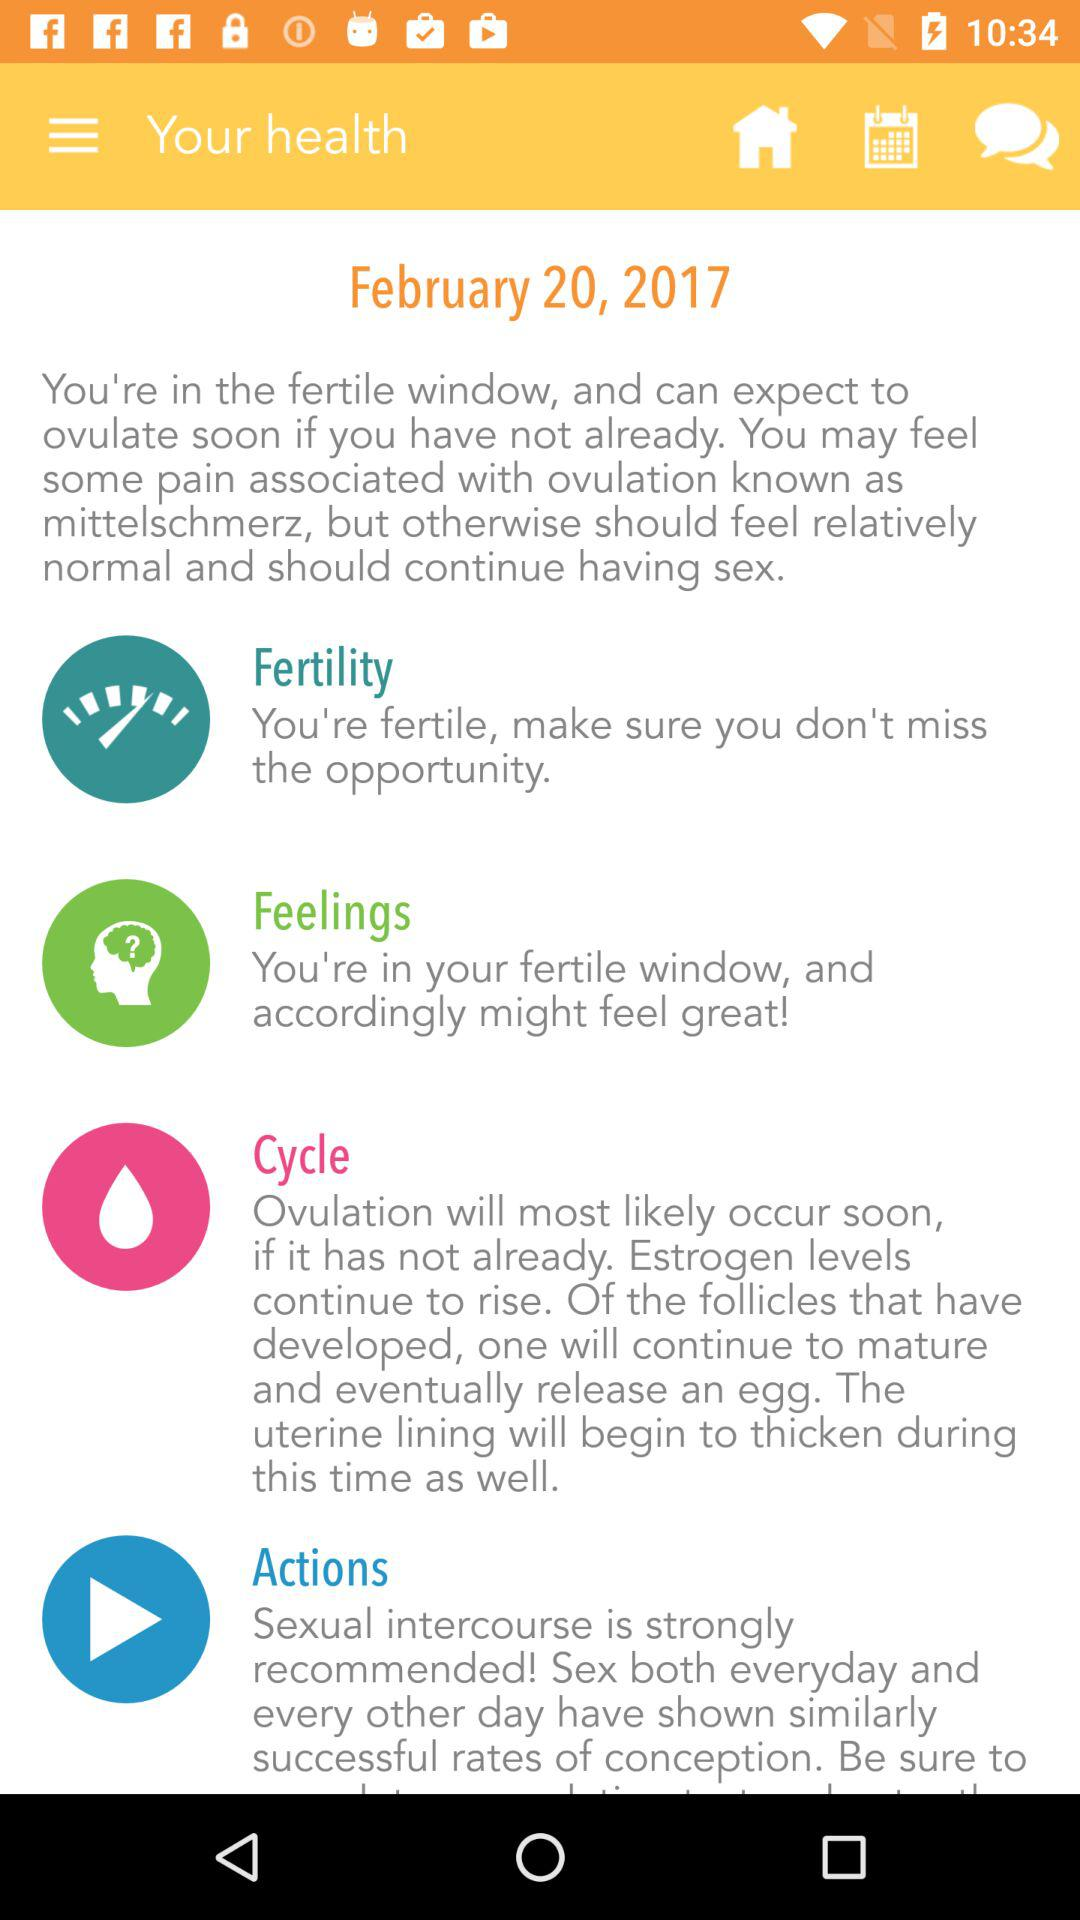What is the given date? The given date is February 20, 2017. 